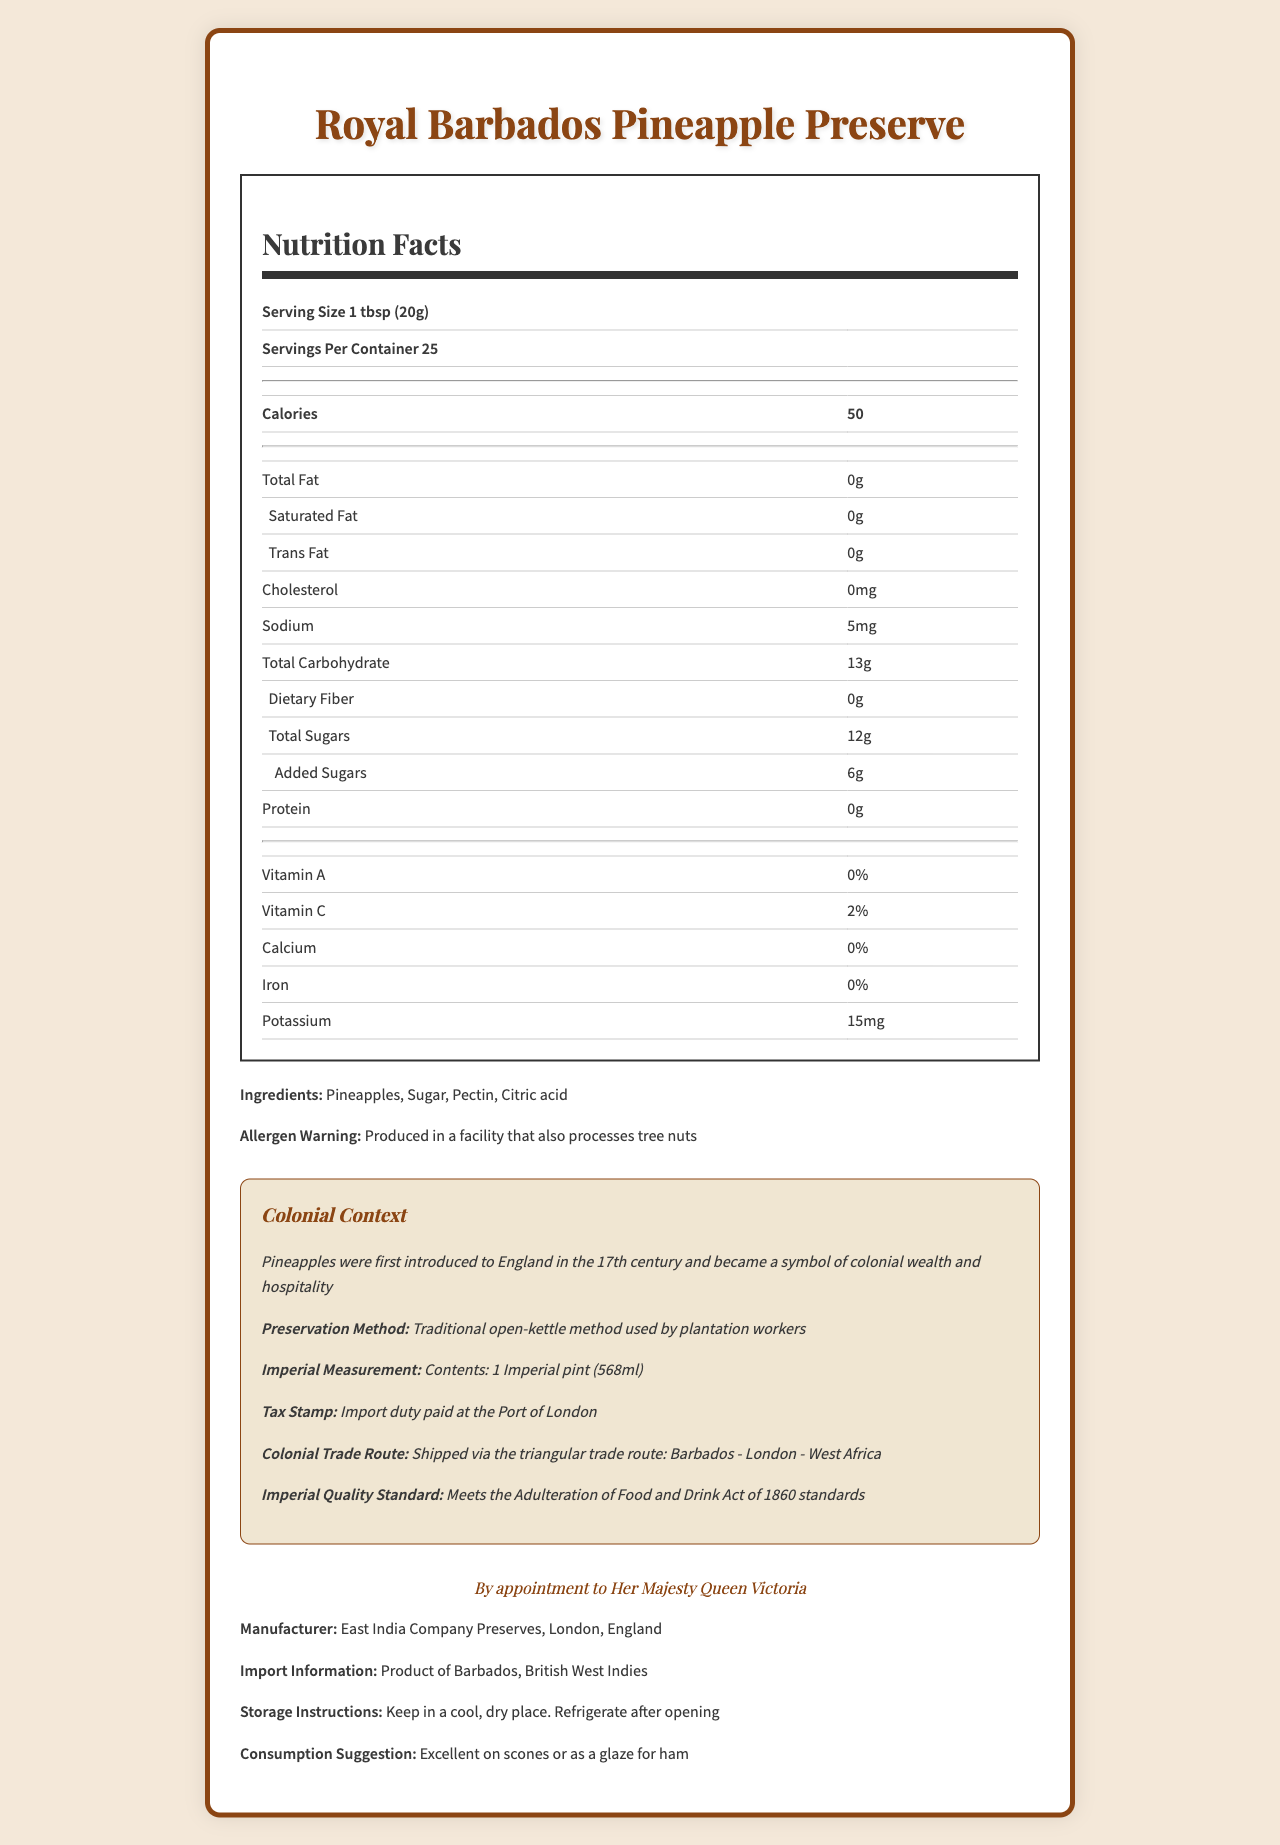who is the manufacturer of the Royal Barbados Pineapple Preserve? The document lists the manufacturer as East India Company Preserves located in London, England.
Answer: East India Company Preserves, London, England what is the serving size for the Royal Barbados Pineapple Preserve? The document states that the serving size for the product is 1 tbsp (20g).
Answer: 1 tbsp (20g) how many calories are in one serving of the Royal Barbados Pineapple Preserve? The Nutrition Facts section of the document indicates that there are 50 calories per serving.
Answer: 50 what preservation method is used for this product? The colonial context section of the document states that the preservation method used is the traditional open-kettle method used by plantation workers.
Answer: Traditional open-kettle method used by plantation workers how much sodium is in one serving of the Royal Barbados Pineapple Preserve? The Nutrition Facts section shows that there is 5mg of sodium per serving.
Answer: 5mg what is the recommended storage instruction for this product? The storage instruction provided in the document is to keep the product in a cool, dry place and to refrigerate after opening.
Answer: Keep in a cool, dry place. Refrigerate after opening which vitamins does one serving of the Royal Barbados Pineapple Preserve provide? A. Vitamin A B. Vitamin C C. Calcium D. Iron The Nutrition Facts section indicates that one serving provides 2% of the daily value for Vitamin C.
Answer: B what is the content volume of the Royal Barbados Pineapple Preserve in imperial measurement? A. 500ml B. 568ml C. 600ml D. 1 liter The document specifies that the content volume in imperial measurement is 1 Imperial pint, which is equivalent to 568ml.
Answer: B does this product contain any protein? According to the Nutrition Facts section, the product has 0g of protein per serving.
Answer: No what allergen warning is associated with this product? The ingredients section of the document includes an allergen warning that states the product is produced in a facility that also processes tree nuts.
Answer: Produced in a facility that also processes tree nuts describe the main idea of the document. The document includes a comprehensive overview of the Royal Barbados Pineapple Preserve, highlighting its nutritional content, historical and colonial significance, as well as additional attributes such as storage instructions and consumption suggestions.
Answer: The document provides detailed information about the Royal Barbados Pineapple Preserve, including its nutritional facts, ingredients, allergen warnings, preservation method, colonial context, and other relevant details for consumers and historians. what is the significance of pineapples during the colonial era mentioned in the document? The colonial context section mentions that pineapples became a symbol of colonial wealth and hospitality when they were introduced to England in the 17th century.
Answer: Symbol of colonial wealth and hospitality what is the import information for the Royal Barbados Pineapple Preserve? The document states that the product is imported from Barbados, British West Indies.
Answer: Product of Barbados, British West Indies does the document mention the source of added sugars in the Royal Barbados Pineapple Preserve? The document only mentions the presence of added sugars (6g per serving) but does not specify the source of these added sugars.
Answer: Not enough information 